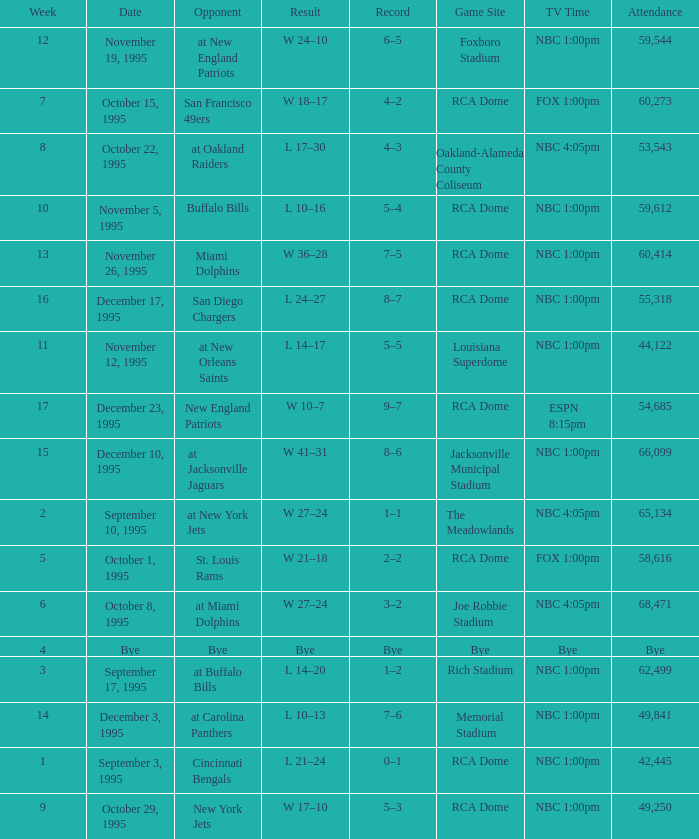What's the Opponent with a Week that's larger than 16? New England Patriots. 